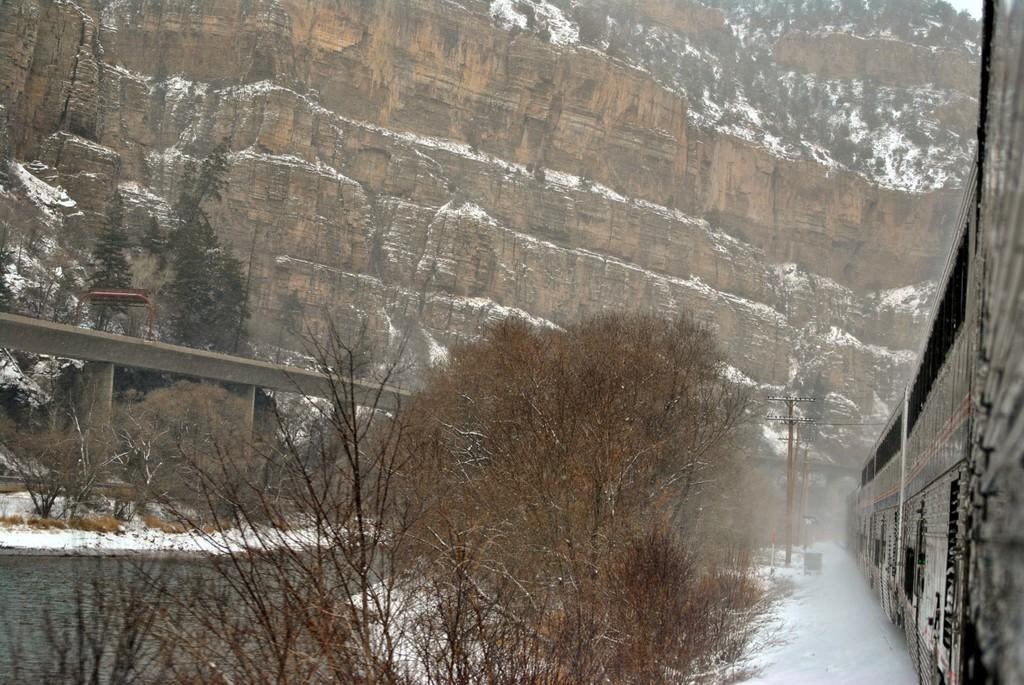What type of vegetation can be seen in the image? There are trees in the image. What structure is present in the image? There is a railing in the image. What geographical feature is visible in the image? There are hills in the image. What mode of transportation can be seen on the right side of the image? There is a train on the track on the right side of the image. What man-made structures are present in the image? There are utility poles in the image. Can you tell me how many ducks are swimming in the river in the image? There is no river or ducks present in the image. What type of agreement is being discussed by the people in the image? There are no people or discussions about agreements in the image. 